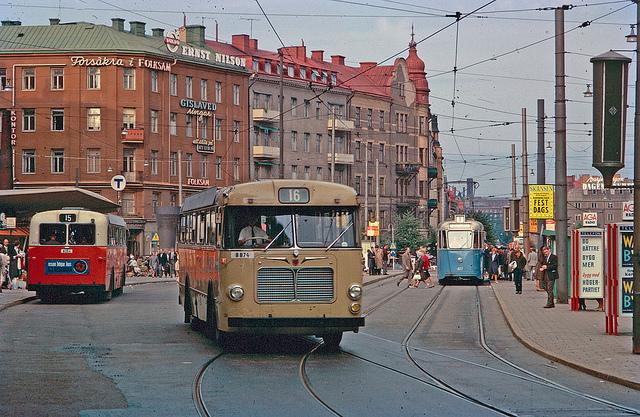How many buses are in the photo?
Write a very short answer. 2. What number is on the bus closest to the camera?
Quick response, please. 16. What number is on the front of the trolley?
Concise answer only. 16. Is the traffic moving?
Keep it brief. Yes. Is this bus at a bus station?
Quick response, please. No. What are the colors on the building roof's on the left?
Keep it brief. Green. What kind of busses are those?
Write a very short answer. Passenger. 